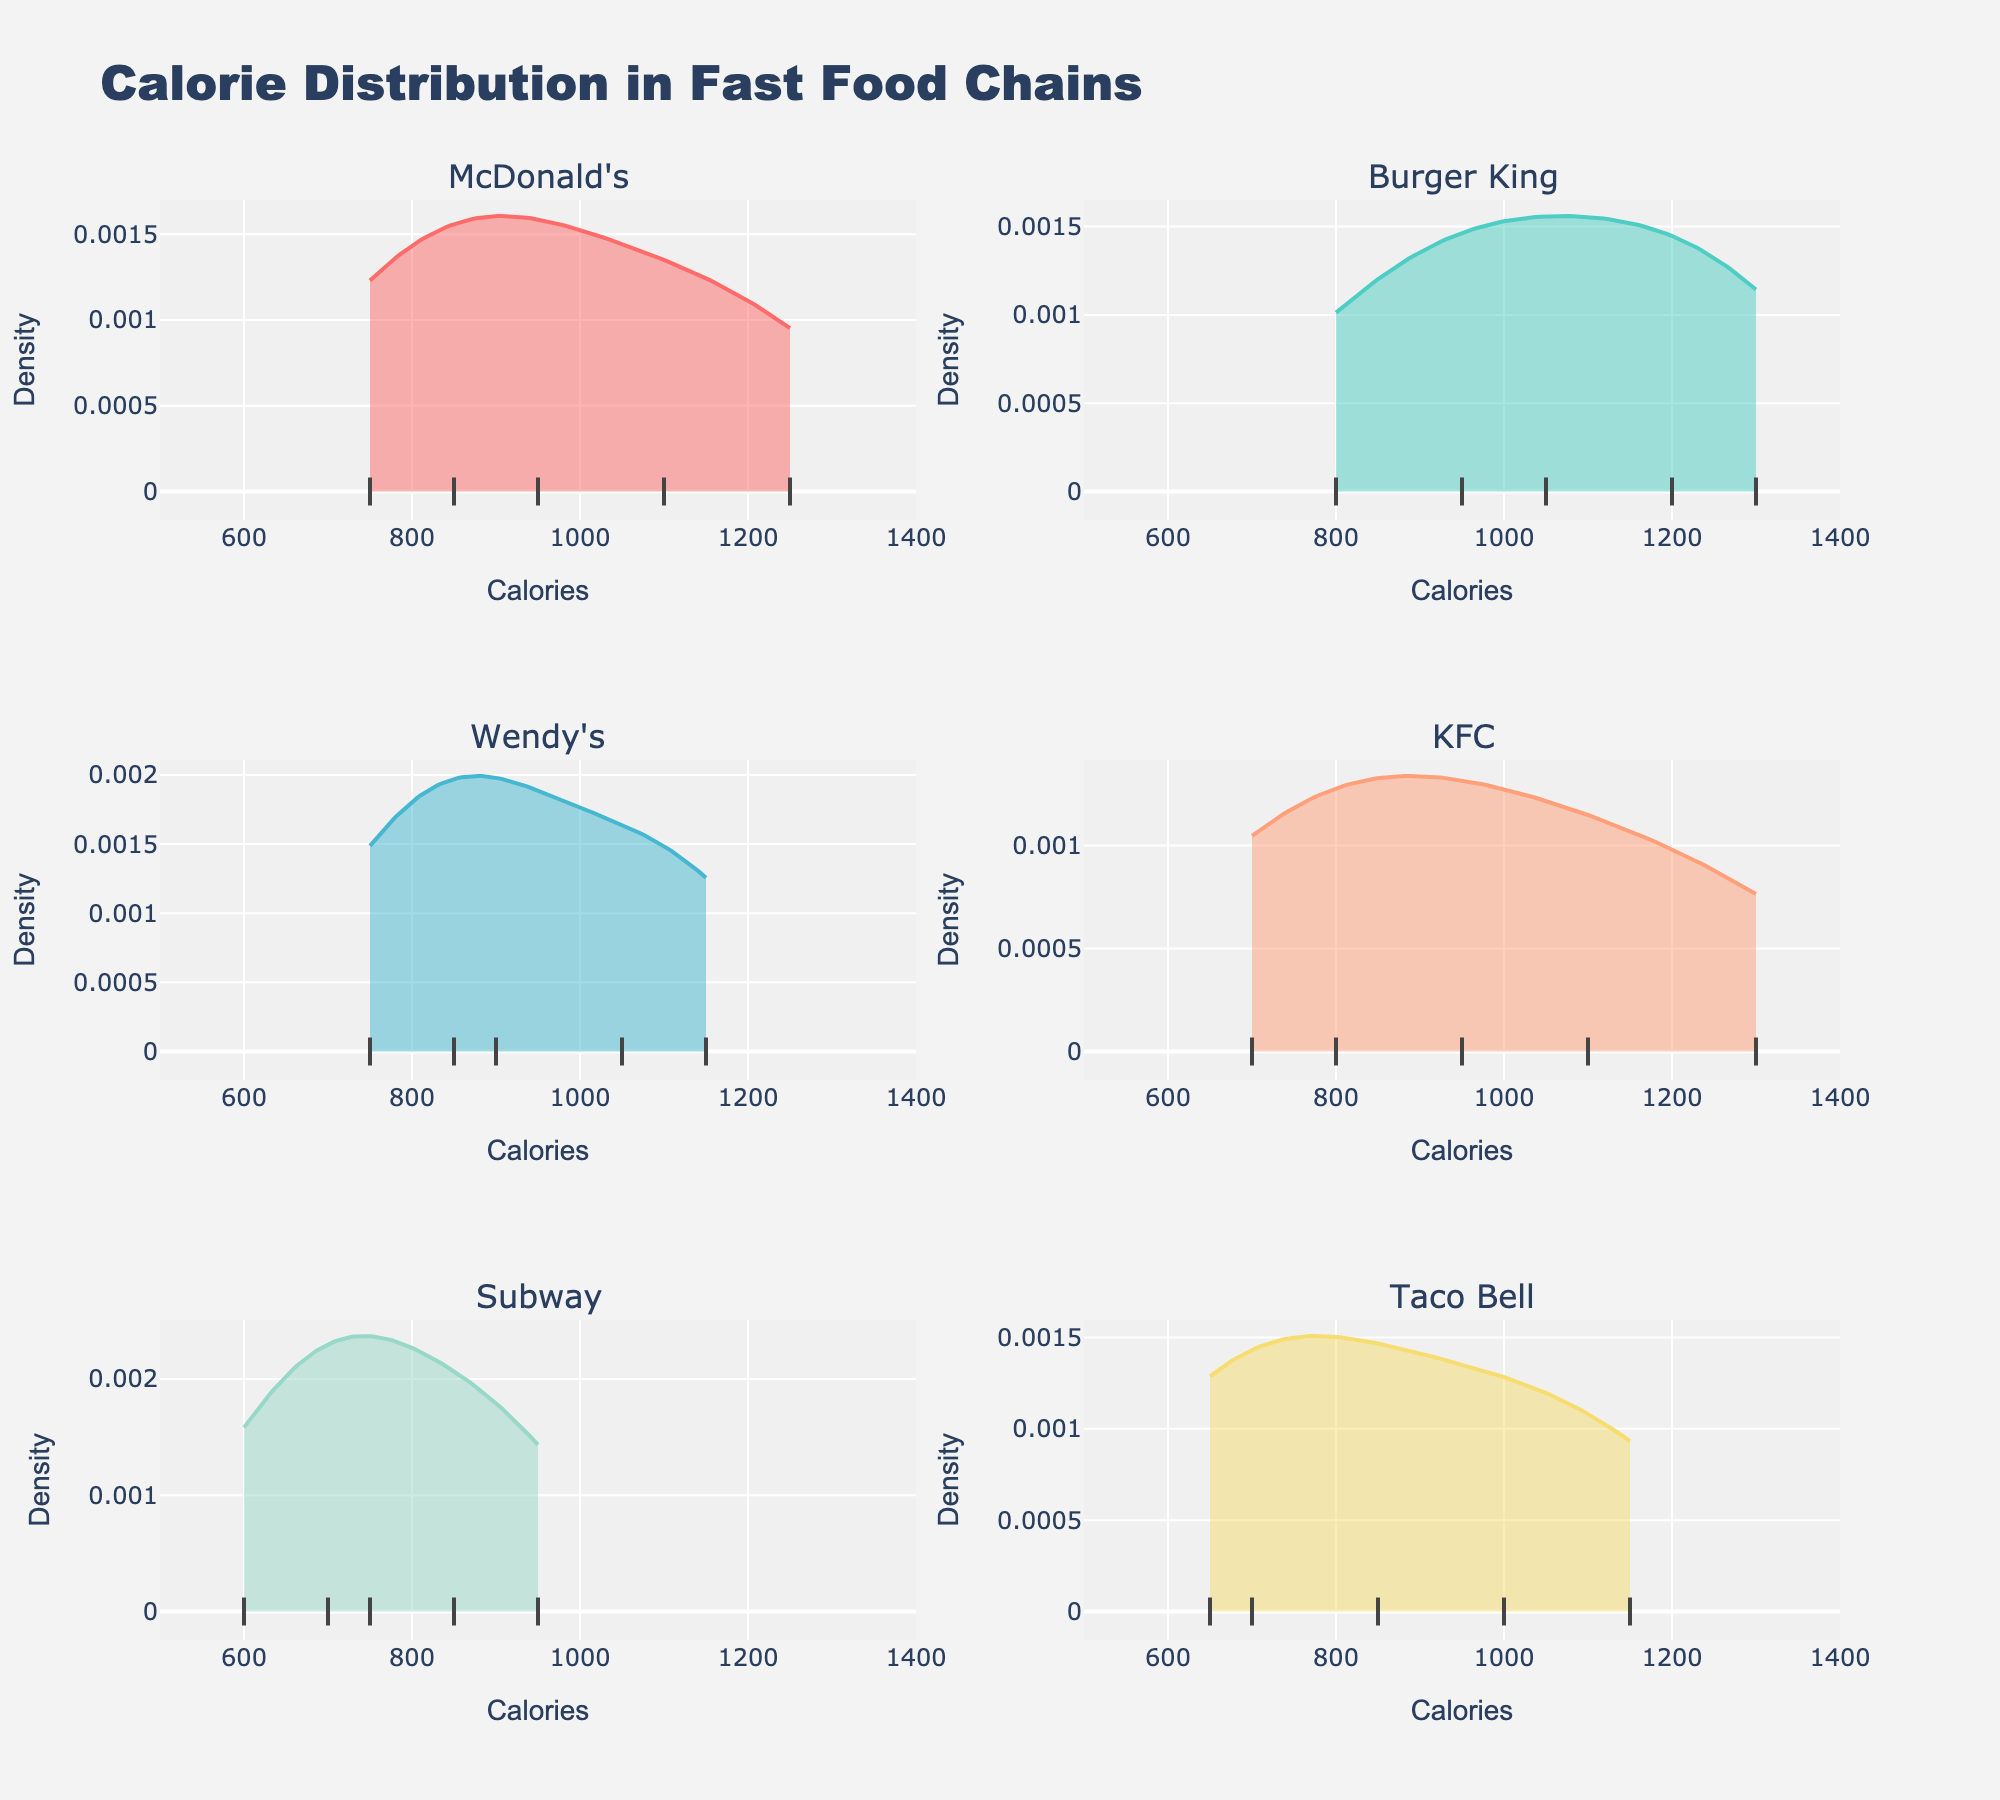What is the title of the plot? The title is displayed at the top of the plot and reads "Calorie Distribution in Fast Food Chains".
Answer: Calorie Distribution in Fast Food Chains Which restaurant chain has the highest peak in the density plot? Look for the plot with the tallest peak in its density curve.
Answer: Burger King What is the range of calories covered in the x-axis? The x-axis range is from the leftmost to the rightmost tick mark visible on the x-axis.
Answer: 500 to 1400 How many subplots are there in the figure? The subplots are displayed in a grid layout within the plot.
Answer: 6 Which restaurant chain has the lowest minimum calorie value? Identify the restaurant chain with data points at the furthest left within each subplot.
Answer: KFC Between McDonald's and Subway, which has a wider spread of calorie values? Compare the density curves of both restaurants to see which one extends over a larger range of calories.
Answer: McDonald's For which restaurant chain does the calorie density peak closest to 1000 calories? Look for the peak of the density curve nearest to the 1000-calorie mark on the x-axis.
Answer: Taco Bell What color is used for Wendy's density plot? Identify the color assigned to Wendy's subplot in the figure.
Answer: Light blue Which restaurant chain shows the least density near the 800-calorie mark? Check the density values at the 800-calorie mark for all subplots and identify the lowest one.
Answer: KFC What does the y-axis represent in these plots? The y-axis scale and label indicate what is plotted on this axis.
Answer: Density 